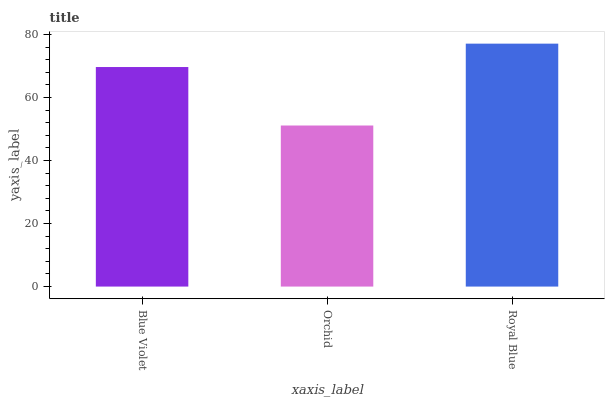Is Orchid the minimum?
Answer yes or no. Yes. Is Royal Blue the maximum?
Answer yes or no. Yes. Is Royal Blue the minimum?
Answer yes or no. No. Is Orchid the maximum?
Answer yes or no. No. Is Royal Blue greater than Orchid?
Answer yes or no. Yes. Is Orchid less than Royal Blue?
Answer yes or no. Yes. Is Orchid greater than Royal Blue?
Answer yes or no. No. Is Royal Blue less than Orchid?
Answer yes or no. No. Is Blue Violet the high median?
Answer yes or no. Yes. Is Blue Violet the low median?
Answer yes or no. Yes. Is Royal Blue the high median?
Answer yes or no. No. Is Royal Blue the low median?
Answer yes or no. No. 